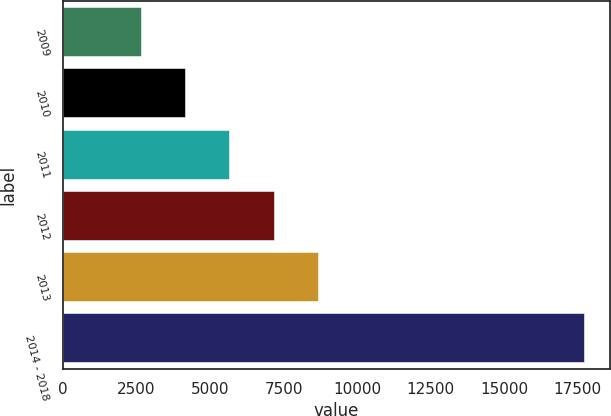Convert chart. <chart><loc_0><loc_0><loc_500><loc_500><bar_chart><fcel>2009<fcel>2010<fcel>2011<fcel>2012<fcel>2013<fcel>2014 - 2018<nl><fcel>2643<fcel>4149.5<fcel>5656<fcel>7162.5<fcel>8669<fcel>17708<nl></chart> 